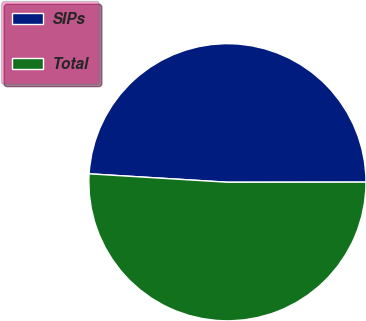<chart> <loc_0><loc_0><loc_500><loc_500><pie_chart><fcel>SIPs<fcel>Total<nl><fcel>49.02%<fcel>50.98%<nl></chart> 